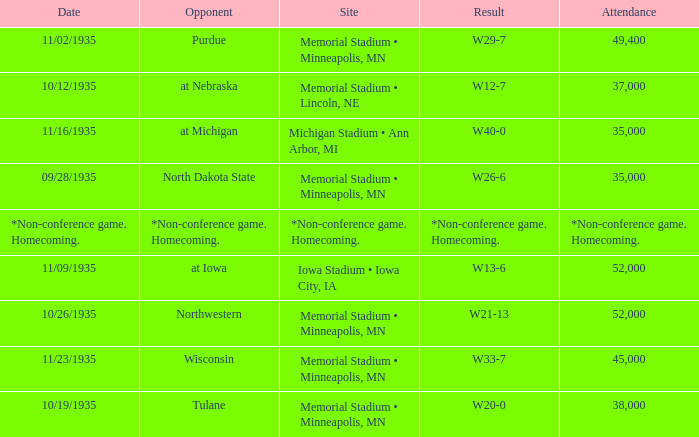How many spectators attended the game that ended in a result of w29-7? 49400.0. 